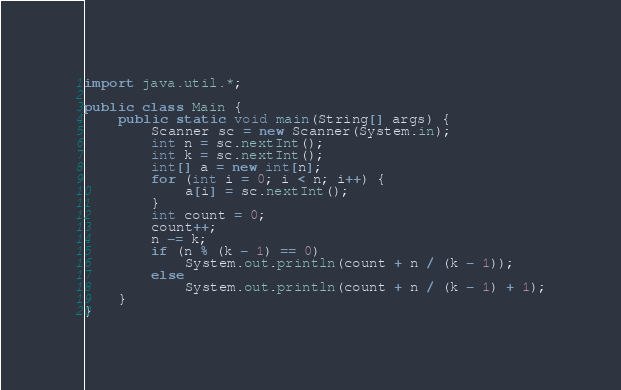Convert code to text. <code><loc_0><loc_0><loc_500><loc_500><_Java_>import java.util.*;

public class Main {
    public static void main(String[] args) {
        Scanner sc = new Scanner(System.in);
        int n = sc.nextInt();
        int k = sc.nextInt();
        int[] a = new int[n];
        for (int i = 0; i < n; i++) {
            a[i] = sc.nextInt();
        }
        int count = 0;
        count++;
        n -= k;
        if (n % (k - 1) == 0)
            System.out.println(count + n / (k - 1));
        else
            System.out.println(count + n / (k - 1) + 1);
    }
}
</code> 